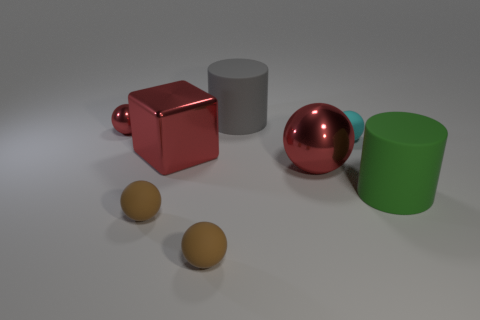Is the number of tiny yellow things greater than the number of objects?
Your answer should be compact. No. There is a metal ball that is left of the large gray cylinder; is its color the same as the big metallic thing that is behind the large metallic ball?
Your answer should be very brief. Yes. Is there a rubber cylinder behind the big rubber cylinder on the right side of the big shiny sphere?
Your response must be concise. Yes. Is the number of large balls right of the small cyan rubber ball less than the number of big cylinders that are on the right side of the large gray cylinder?
Your answer should be compact. Yes. Does the thing behind the small metal ball have the same material as the cylinder on the right side of the cyan thing?
Offer a very short reply. Yes. How many tiny things are either metal things or rubber spheres?
Provide a short and direct response. 4. The cyan thing that is made of the same material as the large gray cylinder is what shape?
Provide a short and direct response. Sphere. Is the number of large red things that are behind the tiny cyan sphere less than the number of gray matte cylinders?
Give a very brief answer. Yes. Do the tiny metallic thing and the tiny cyan rubber object have the same shape?
Provide a short and direct response. Yes. How many rubber objects are big brown objects or green things?
Provide a short and direct response. 1. 